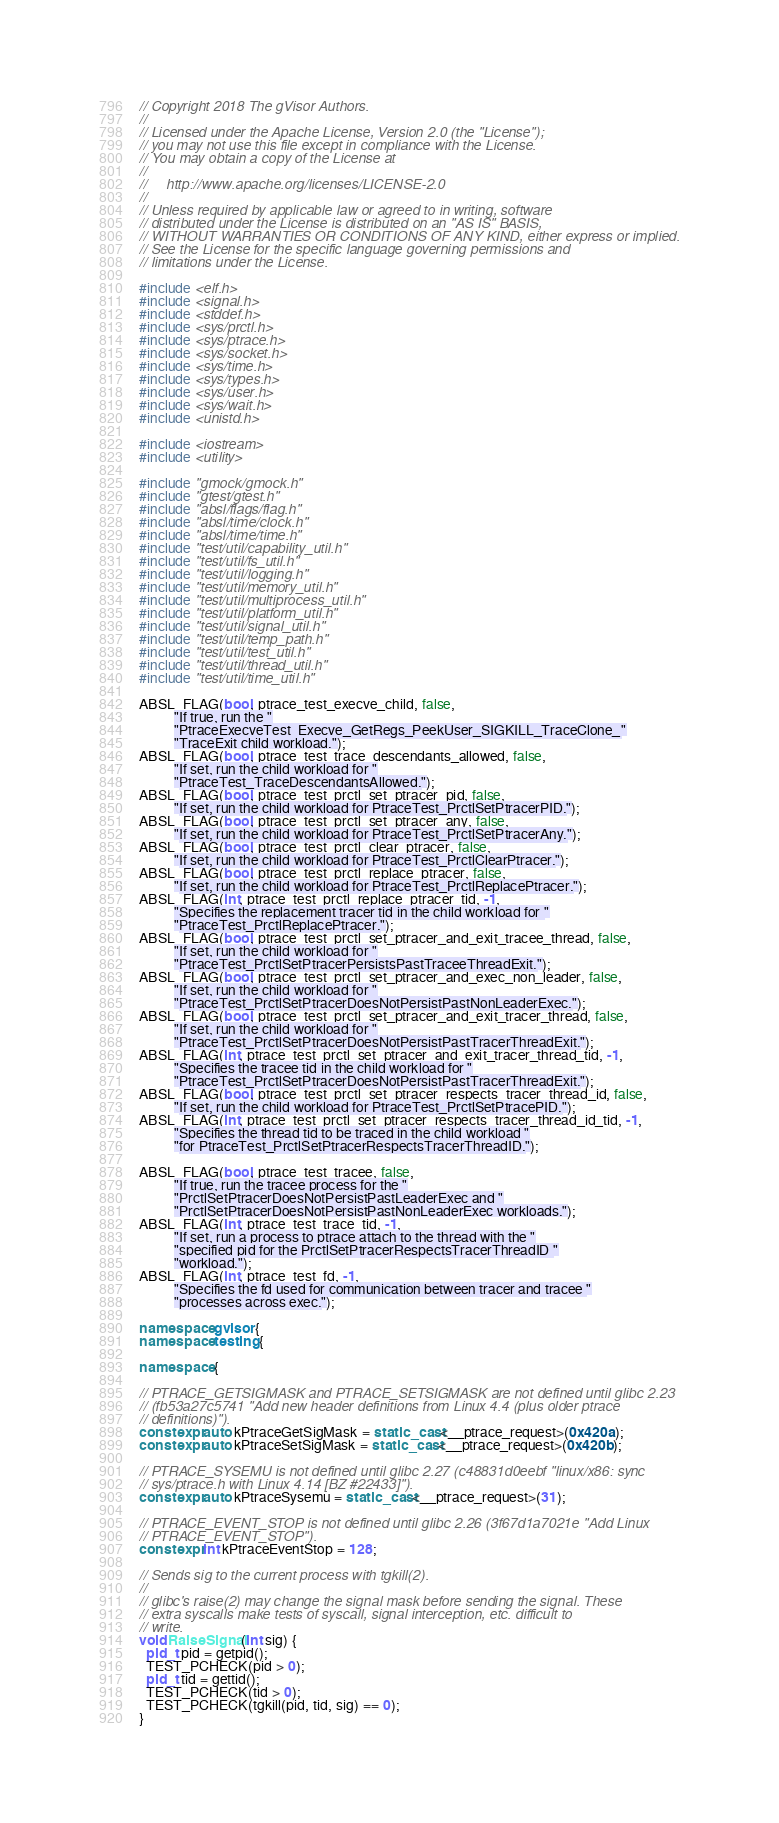Convert code to text. <code><loc_0><loc_0><loc_500><loc_500><_C++_>// Copyright 2018 The gVisor Authors.
//
// Licensed under the Apache License, Version 2.0 (the "License");
// you may not use this file except in compliance with the License.
// You may obtain a copy of the License at
//
//     http://www.apache.org/licenses/LICENSE-2.0
//
// Unless required by applicable law or agreed to in writing, software
// distributed under the License is distributed on an "AS IS" BASIS,
// WITHOUT WARRANTIES OR CONDITIONS OF ANY KIND, either express or implied.
// See the License for the specific language governing permissions and
// limitations under the License.

#include <elf.h>
#include <signal.h>
#include <stddef.h>
#include <sys/prctl.h>
#include <sys/ptrace.h>
#include <sys/socket.h>
#include <sys/time.h>
#include <sys/types.h>
#include <sys/user.h>
#include <sys/wait.h>
#include <unistd.h>

#include <iostream>
#include <utility>

#include "gmock/gmock.h"
#include "gtest/gtest.h"
#include "absl/flags/flag.h"
#include "absl/time/clock.h"
#include "absl/time/time.h"
#include "test/util/capability_util.h"
#include "test/util/fs_util.h"
#include "test/util/logging.h"
#include "test/util/memory_util.h"
#include "test/util/multiprocess_util.h"
#include "test/util/platform_util.h"
#include "test/util/signal_util.h"
#include "test/util/temp_path.h"
#include "test/util/test_util.h"
#include "test/util/thread_util.h"
#include "test/util/time_util.h"

ABSL_FLAG(bool, ptrace_test_execve_child, false,
          "If true, run the "
          "PtraceExecveTest_Execve_GetRegs_PeekUser_SIGKILL_TraceClone_"
          "TraceExit child workload.");
ABSL_FLAG(bool, ptrace_test_trace_descendants_allowed, false,
          "If set, run the child workload for "
          "PtraceTest_TraceDescendantsAllowed.");
ABSL_FLAG(bool, ptrace_test_prctl_set_ptracer_pid, false,
          "If set, run the child workload for PtraceTest_PrctlSetPtracerPID.");
ABSL_FLAG(bool, ptrace_test_prctl_set_ptracer_any, false,
          "If set, run the child workload for PtraceTest_PrctlSetPtracerAny.");
ABSL_FLAG(bool, ptrace_test_prctl_clear_ptracer, false,
          "If set, run the child workload for PtraceTest_PrctlClearPtracer.");
ABSL_FLAG(bool, ptrace_test_prctl_replace_ptracer, false,
          "If set, run the child workload for PtraceTest_PrctlReplacePtracer.");
ABSL_FLAG(int, ptrace_test_prctl_replace_ptracer_tid, -1,
          "Specifies the replacement tracer tid in the child workload for "
          "PtraceTest_PrctlReplacePtracer.");
ABSL_FLAG(bool, ptrace_test_prctl_set_ptracer_and_exit_tracee_thread, false,
          "If set, run the child workload for "
          "PtraceTest_PrctlSetPtracerPersistsPastTraceeThreadExit.");
ABSL_FLAG(bool, ptrace_test_prctl_set_ptracer_and_exec_non_leader, false,
          "If set, run the child workload for "
          "PtraceTest_PrctlSetPtracerDoesNotPersistPastNonLeaderExec.");
ABSL_FLAG(bool, ptrace_test_prctl_set_ptracer_and_exit_tracer_thread, false,
          "If set, run the child workload for "
          "PtraceTest_PrctlSetPtracerDoesNotPersistPastTracerThreadExit.");
ABSL_FLAG(int, ptrace_test_prctl_set_ptracer_and_exit_tracer_thread_tid, -1,
          "Specifies the tracee tid in the child workload for "
          "PtraceTest_PrctlSetPtracerDoesNotPersistPastTracerThreadExit.");
ABSL_FLAG(bool, ptrace_test_prctl_set_ptracer_respects_tracer_thread_id, false,
          "If set, run the child workload for PtraceTest_PrctlSetPtracePID.");
ABSL_FLAG(int, ptrace_test_prctl_set_ptracer_respects_tracer_thread_id_tid, -1,
          "Specifies the thread tid to be traced in the child workload "
          "for PtraceTest_PrctlSetPtracerRespectsTracerThreadID.");

ABSL_FLAG(bool, ptrace_test_tracee, false,
          "If true, run the tracee process for the "
          "PrctlSetPtracerDoesNotPersistPastLeaderExec and "
          "PrctlSetPtracerDoesNotPersistPastNonLeaderExec workloads.");
ABSL_FLAG(int, ptrace_test_trace_tid, -1,
          "If set, run a process to ptrace attach to the thread with the "
          "specified pid for the PrctlSetPtracerRespectsTracerThreadID "
          "workload.");
ABSL_FLAG(int, ptrace_test_fd, -1,
          "Specifies the fd used for communication between tracer and tracee "
          "processes across exec.");

namespace gvisor {
namespace testing {

namespace {

// PTRACE_GETSIGMASK and PTRACE_SETSIGMASK are not defined until glibc 2.23
// (fb53a27c5741 "Add new header definitions from Linux 4.4 (plus older ptrace
// definitions)").
constexpr auto kPtraceGetSigMask = static_cast<__ptrace_request>(0x420a);
constexpr auto kPtraceSetSigMask = static_cast<__ptrace_request>(0x420b);

// PTRACE_SYSEMU is not defined until glibc 2.27 (c48831d0eebf "linux/x86: sync
// sys/ptrace.h with Linux 4.14 [BZ #22433]").
constexpr auto kPtraceSysemu = static_cast<__ptrace_request>(31);

// PTRACE_EVENT_STOP is not defined until glibc 2.26 (3f67d1a7021e "Add Linux
// PTRACE_EVENT_STOP").
constexpr int kPtraceEventStop = 128;

// Sends sig to the current process with tgkill(2).
//
// glibc's raise(2) may change the signal mask before sending the signal. These
// extra syscalls make tests of syscall, signal interception, etc. difficult to
// write.
void RaiseSignal(int sig) {
  pid_t pid = getpid();
  TEST_PCHECK(pid > 0);
  pid_t tid = gettid();
  TEST_PCHECK(tid > 0);
  TEST_PCHECK(tgkill(pid, tid, sig) == 0);
}
</code> 